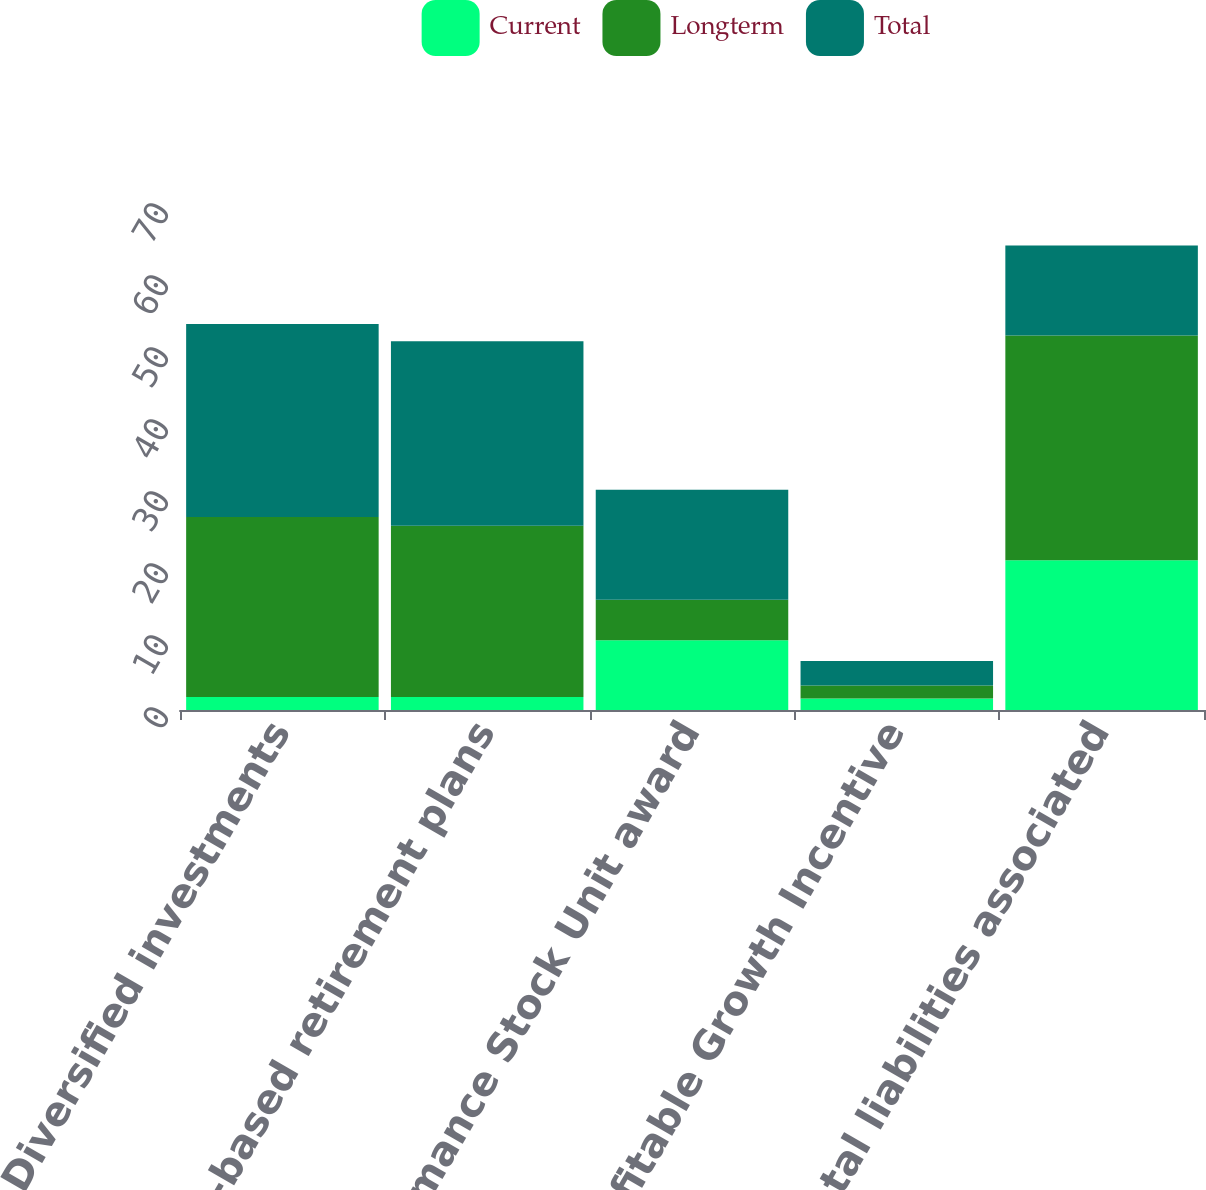Convert chart to OTSL. <chart><loc_0><loc_0><loc_500><loc_500><stacked_bar_chart><ecel><fcel>Diversified investments<fcel>Stock-based retirement plans<fcel>Performance Stock Unit award<fcel>Profitable Growth Incentive<fcel>Total liabilities associated<nl><fcel>Current<fcel>1.8<fcel>1.8<fcel>9.7<fcel>1.6<fcel>20.8<nl><fcel>Longterm<fcel>25<fcel>23.8<fcel>5.6<fcel>1.8<fcel>31.2<nl><fcel>Total<fcel>26.8<fcel>25.6<fcel>15.3<fcel>3.4<fcel>12.5<nl></chart> 